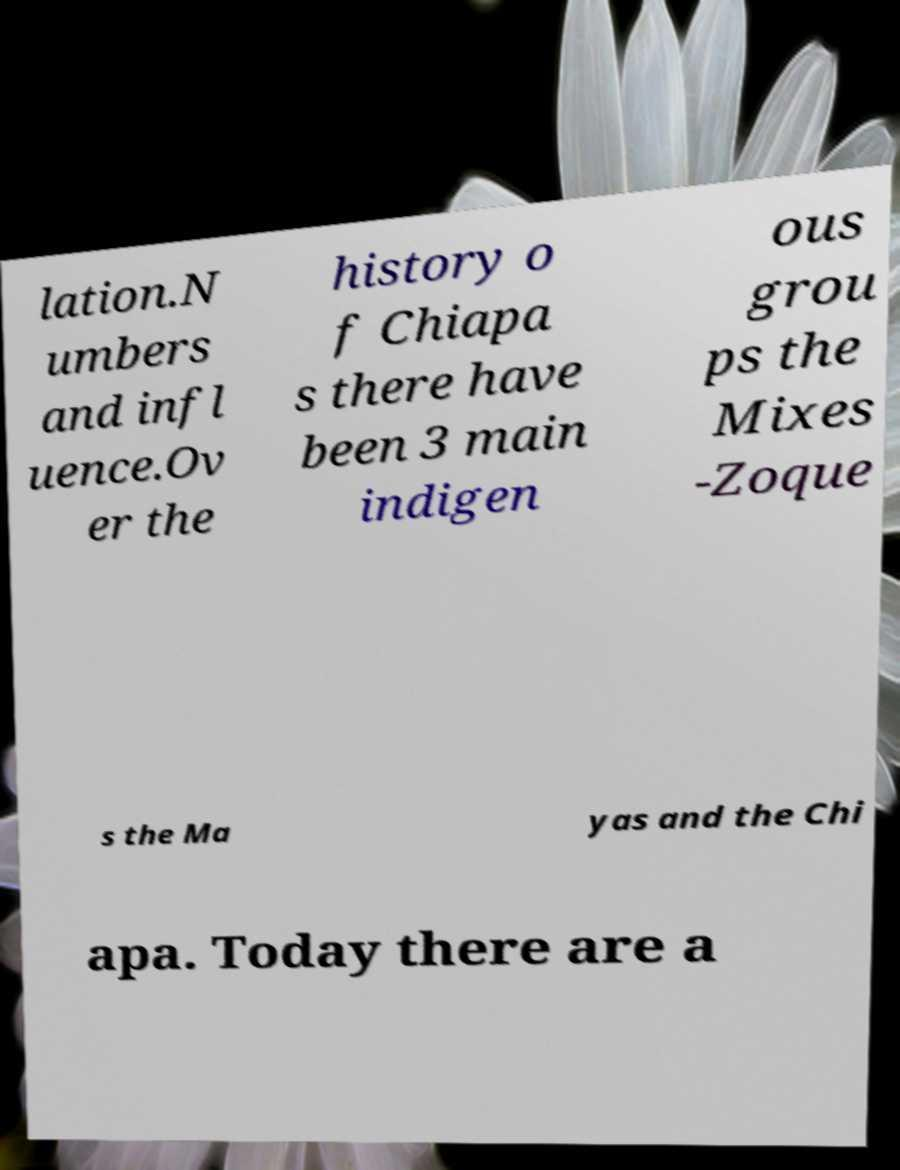What messages or text are displayed in this image? I need them in a readable, typed format. lation.N umbers and infl uence.Ov er the history o f Chiapa s there have been 3 main indigen ous grou ps the Mixes -Zoque s the Ma yas and the Chi apa. Today there are a 